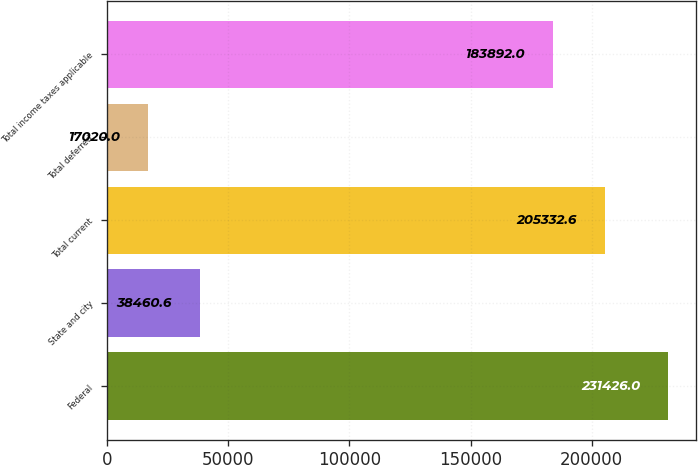Convert chart to OTSL. <chart><loc_0><loc_0><loc_500><loc_500><bar_chart><fcel>Federal<fcel>State and city<fcel>Total current<fcel>Total deferred<fcel>Total income taxes applicable<nl><fcel>231426<fcel>38460.6<fcel>205333<fcel>17020<fcel>183892<nl></chart> 